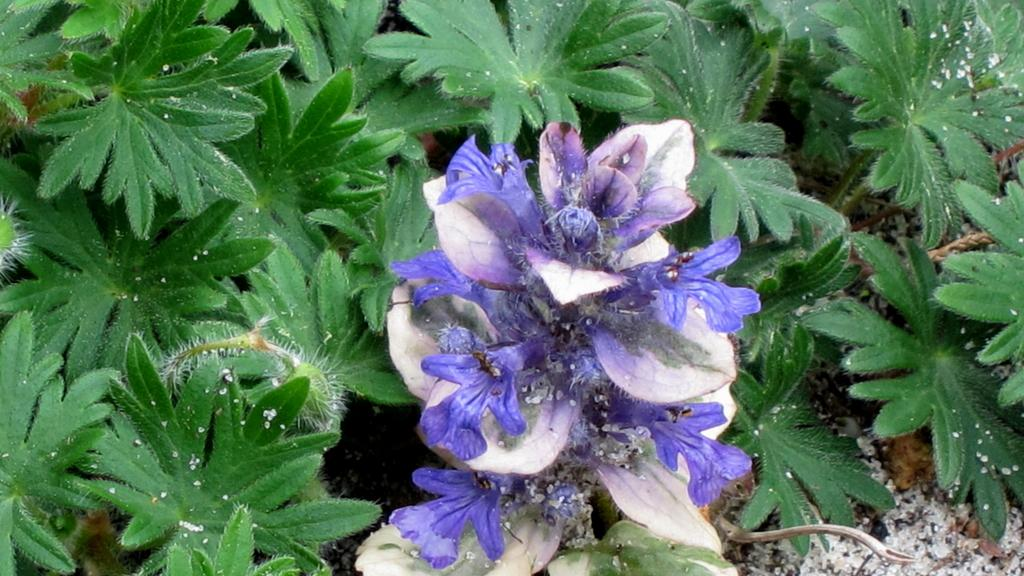What colors are the flowers in the image? The flowers in the image are purple and white. What else can be seen around the flowers? The flowers are surrounded by green leaves. What type of record can be seen playing in the background of the image? There is no record or any audio equipment present in the image; it features flowers and green leaves. 